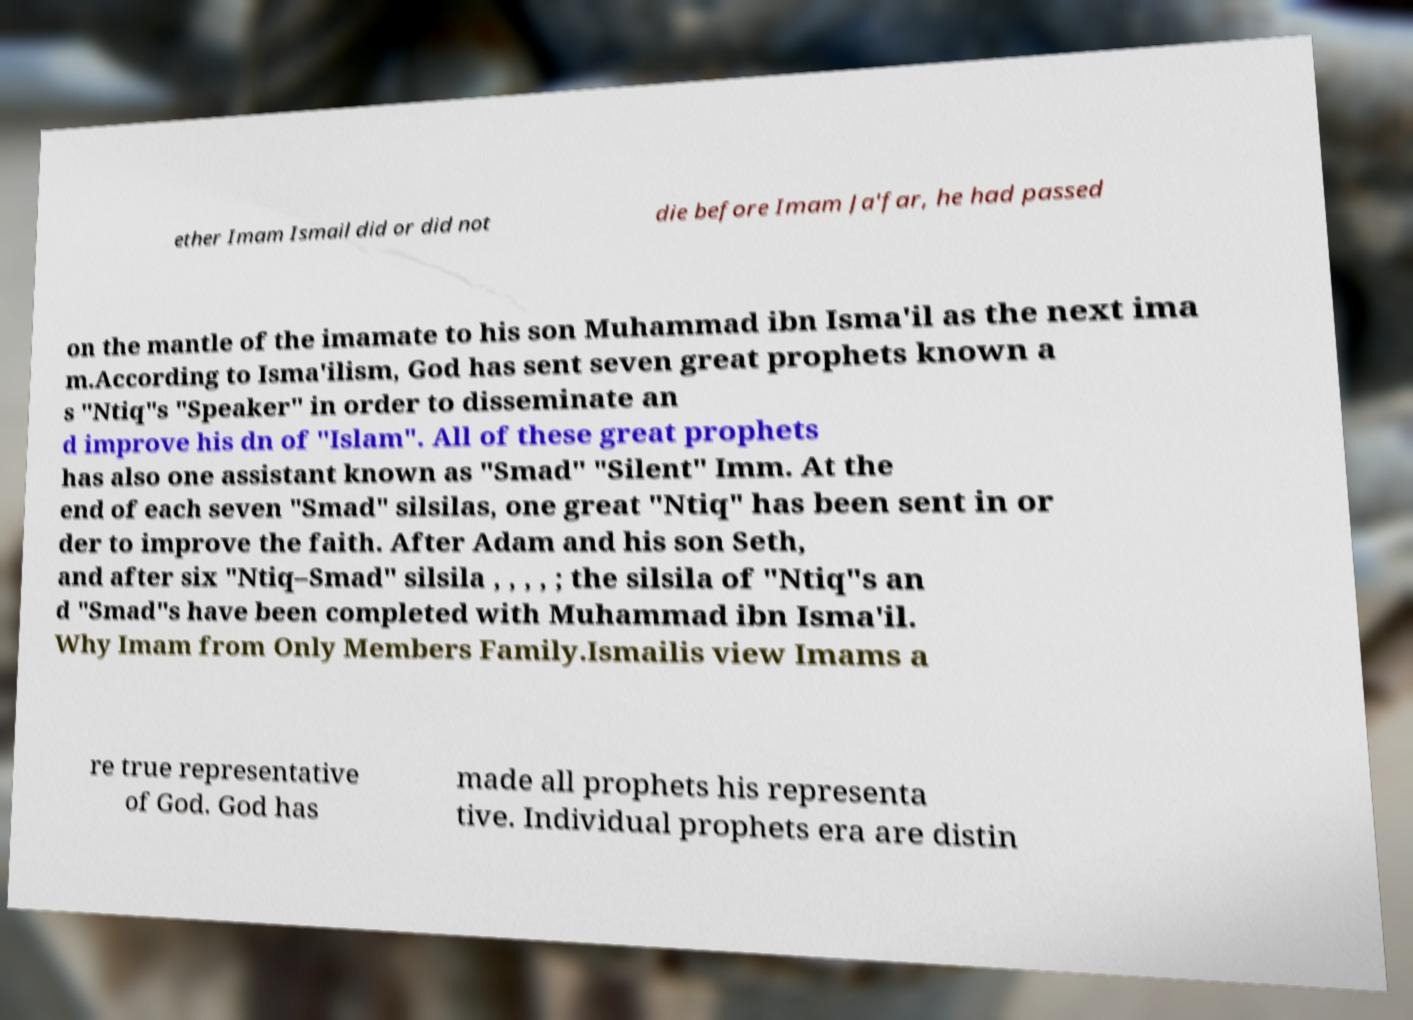Can you read and provide the text displayed in the image?This photo seems to have some interesting text. Can you extract and type it out for me? ether Imam Ismail did or did not die before Imam Ja'far, he had passed on the mantle of the imamate to his son Muhammad ibn Isma'il as the next ima m.According to Isma'ilism, God has sent seven great prophets known a s "Ntiq"s "Speaker" in order to disseminate an d improve his dn of "Islam". All of these great prophets has also one assistant known as "Smad" "Silent" Imm. At the end of each seven "Smad" silsilas, one great "Ntiq" has been sent in or der to improve the faith. After Adam and his son Seth, and after six "Ntiq–Smad" silsila , , , , ; the silsila of "Ntiq"s an d "Smad"s have been completed with Muhammad ibn Isma'il. Why Imam from Only Members Family.Ismailis view Imams a re true representative of God. God has made all prophets his representa tive. Individual prophets era are distin 